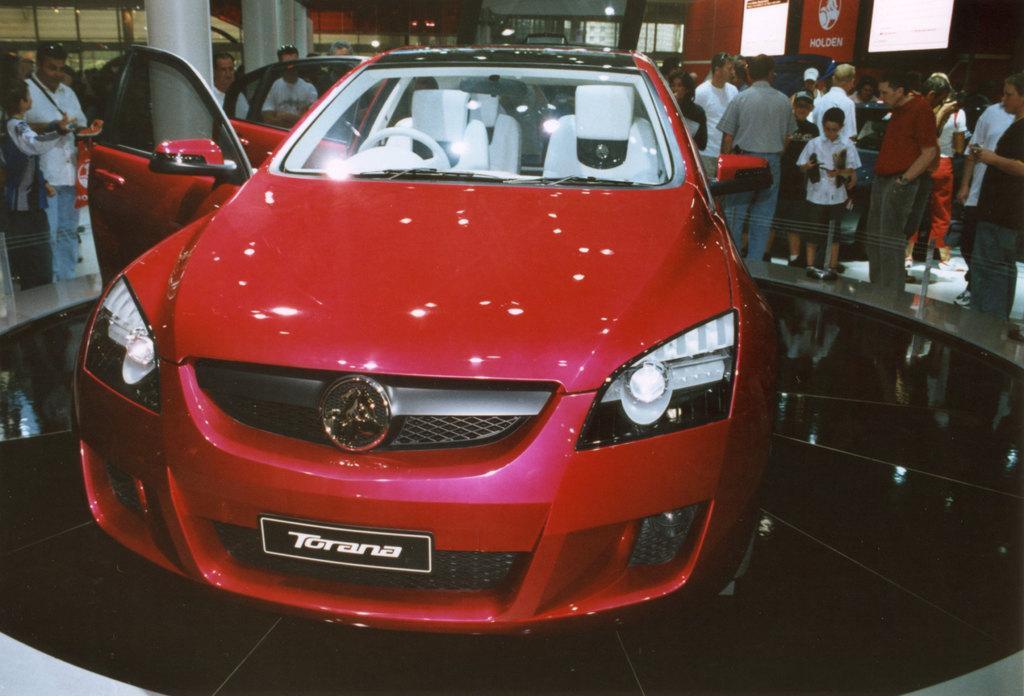How would you summarize this image in a sentence or two? As we can see in the image there is a brand new red colour car standing in between the hall and the brand name is "Torana" and there are spectators around it watching behind them there are hoardings and lights and the two pillars in between the hall. 